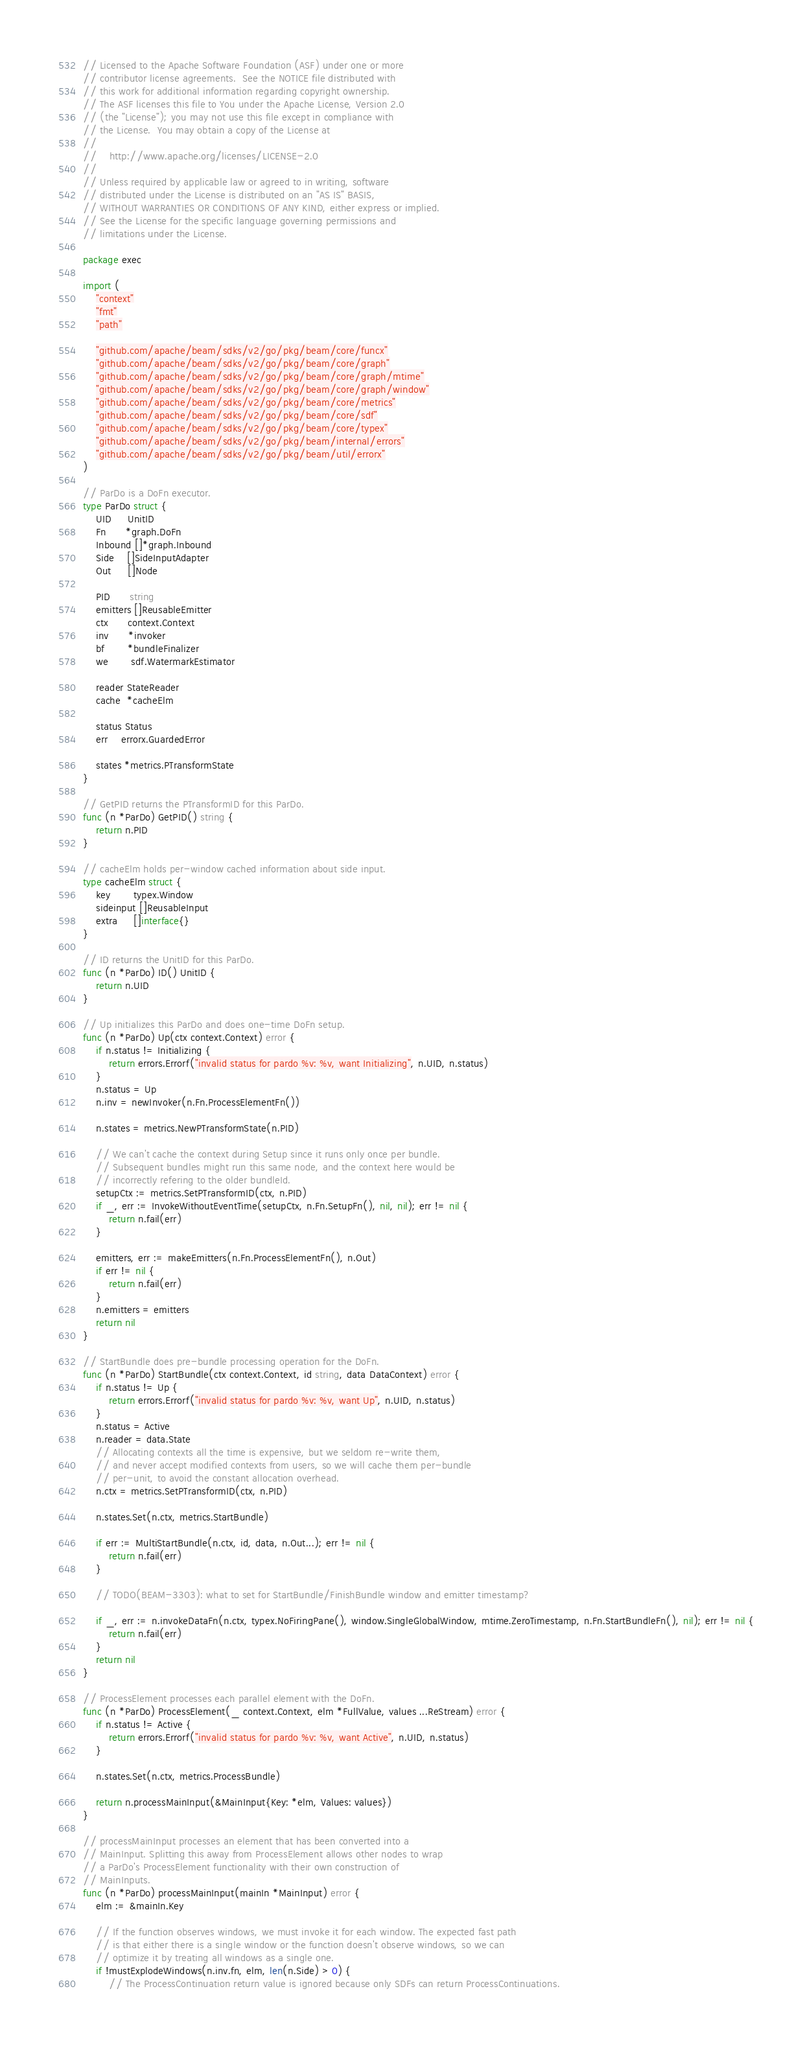Convert code to text. <code><loc_0><loc_0><loc_500><loc_500><_Go_>// Licensed to the Apache Software Foundation (ASF) under one or more
// contributor license agreements.  See the NOTICE file distributed with
// this work for additional information regarding copyright ownership.
// The ASF licenses this file to You under the Apache License, Version 2.0
// (the "License"); you may not use this file except in compliance with
// the License.  You may obtain a copy of the License at
//
//    http://www.apache.org/licenses/LICENSE-2.0
//
// Unless required by applicable law or agreed to in writing, software
// distributed under the License is distributed on an "AS IS" BASIS,
// WITHOUT WARRANTIES OR CONDITIONS OF ANY KIND, either express or implied.
// See the License for the specific language governing permissions and
// limitations under the License.

package exec

import (
	"context"
	"fmt"
	"path"

	"github.com/apache/beam/sdks/v2/go/pkg/beam/core/funcx"
	"github.com/apache/beam/sdks/v2/go/pkg/beam/core/graph"
	"github.com/apache/beam/sdks/v2/go/pkg/beam/core/graph/mtime"
	"github.com/apache/beam/sdks/v2/go/pkg/beam/core/graph/window"
	"github.com/apache/beam/sdks/v2/go/pkg/beam/core/metrics"
	"github.com/apache/beam/sdks/v2/go/pkg/beam/core/sdf"
	"github.com/apache/beam/sdks/v2/go/pkg/beam/core/typex"
	"github.com/apache/beam/sdks/v2/go/pkg/beam/internal/errors"
	"github.com/apache/beam/sdks/v2/go/pkg/beam/util/errorx"
)

// ParDo is a DoFn executor.
type ParDo struct {
	UID     UnitID
	Fn      *graph.DoFn
	Inbound []*graph.Inbound
	Side    []SideInputAdapter
	Out     []Node

	PID      string
	emitters []ReusableEmitter
	ctx      context.Context
	inv      *invoker
	bf       *bundleFinalizer
	we       sdf.WatermarkEstimator

	reader StateReader
	cache  *cacheElm

	status Status
	err    errorx.GuardedError

	states *metrics.PTransformState
}

// GetPID returns the PTransformID for this ParDo.
func (n *ParDo) GetPID() string {
	return n.PID
}

// cacheElm holds per-window cached information about side input.
type cacheElm struct {
	key       typex.Window
	sideinput []ReusableInput
	extra     []interface{}
}

// ID returns the UnitID for this ParDo.
func (n *ParDo) ID() UnitID {
	return n.UID
}

// Up initializes this ParDo and does one-time DoFn setup.
func (n *ParDo) Up(ctx context.Context) error {
	if n.status != Initializing {
		return errors.Errorf("invalid status for pardo %v: %v, want Initializing", n.UID, n.status)
	}
	n.status = Up
	n.inv = newInvoker(n.Fn.ProcessElementFn())

	n.states = metrics.NewPTransformState(n.PID)

	// We can't cache the context during Setup since it runs only once per bundle.
	// Subsequent bundles might run this same node, and the context here would be
	// incorrectly refering to the older bundleId.
	setupCtx := metrics.SetPTransformID(ctx, n.PID)
	if _, err := InvokeWithoutEventTime(setupCtx, n.Fn.SetupFn(), nil, nil); err != nil {
		return n.fail(err)
	}

	emitters, err := makeEmitters(n.Fn.ProcessElementFn(), n.Out)
	if err != nil {
		return n.fail(err)
	}
	n.emitters = emitters
	return nil
}

// StartBundle does pre-bundle processing operation for the DoFn.
func (n *ParDo) StartBundle(ctx context.Context, id string, data DataContext) error {
	if n.status != Up {
		return errors.Errorf("invalid status for pardo %v: %v, want Up", n.UID, n.status)
	}
	n.status = Active
	n.reader = data.State
	// Allocating contexts all the time is expensive, but we seldom re-write them,
	// and never accept modified contexts from users, so we will cache them per-bundle
	// per-unit, to avoid the constant allocation overhead.
	n.ctx = metrics.SetPTransformID(ctx, n.PID)

	n.states.Set(n.ctx, metrics.StartBundle)

	if err := MultiStartBundle(n.ctx, id, data, n.Out...); err != nil {
		return n.fail(err)
	}

	// TODO(BEAM-3303): what to set for StartBundle/FinishBundle window and emitter timestamp?

	if _, err := n.invokeDataFn(n.ctx, typex.NoFiringPane(), window.SingleGlobalWindow, mtime.ZeroTimestamp, n.Fn.StartBundleFn(), nil); err != nil {
		return n.fail(err)
	}
	return nil
}

// ProcessElement processes each parallel element with the DoFn.
func (n *ParDo) ProcessElement(_ context.Context, elm *FullValue, values ...ReStream) error {
	if n.status != Active {
		return errors.Errorf("invalid status for pardo %v: %v, want Active", n.UID, n.status)
	}

	n.states.Set(n.ctx, metrics.ProcessBundle)

	return n.processMainInput(&MainInput{Key: *elm, Values: values})
}

// processMainInput processes an element that has been converted into a
// MainInput. Splitting this away from ProcessElement allows other nodes to wrap
// a ParDo's ProcessElement functionality with their own construction of
// MainInputs.
func (n *ParDo) processMainInput(mainIn *MainInput) error {
	elm := &mainIn.Key

	// If the function observes windows, we must invoke it for each window. The expected fast path
	// is that either there is a single window or the function doesn't observe windows, so we can
	// optimize it by treating all windows as a single one.
	if !mustExplodeWindows(n.inv.fn, elm, len(n.Side) > 0) {
		// The ProcessContinuation return value is ignored because only SDFs can return ProcessContinuations.</code> 